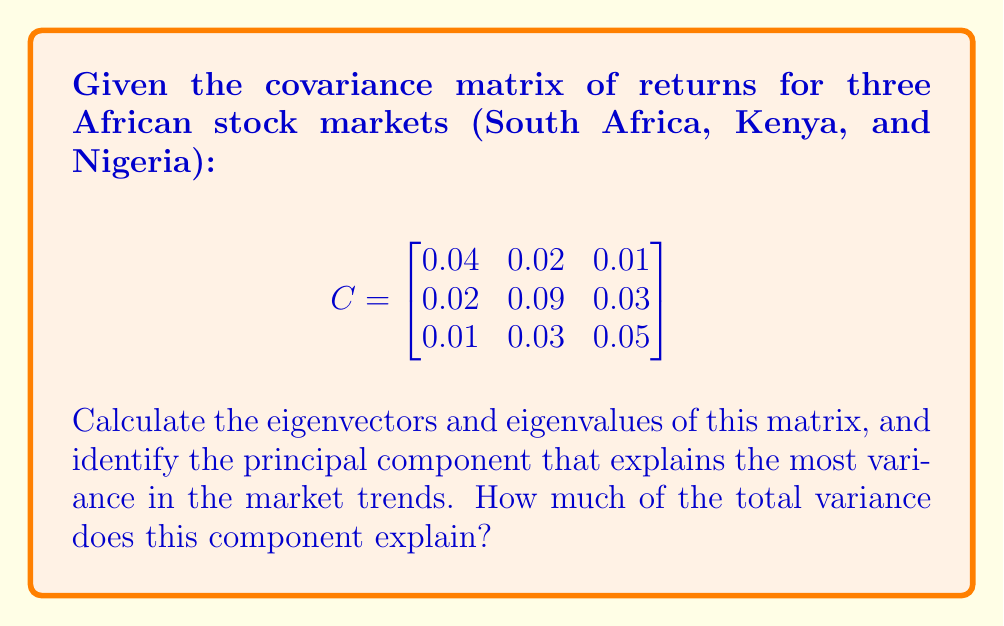Can you answer this question? 1) To find eigenvectors and eigenvalues, we solve the characteristic equation:
   $\det(C - \lambda I) = 0$

2) Expanding the determinant:
   $$(0.04-\lambda)(0.09-\lambda)(0.05-\lambda) - 0.02^2(0.05-\lambda) - 0.01^2(0.09-\lambda) - 0.03^2(0.04-\lambda) + 2(0.02)(0.01)(0.03) = 0$$

3) Solving this equation (using a computer algebra system due to complexity):
   $\lambda_1 \approx 0.1046$
   $\lambda_2 \approx 0.0608$
   $\lambda_3 \approx 0.0246$

4) The corresponding normalized eigenvectors are:
   $$v_1 \approx \begin{bmatrix} 0.2673 \\ 0.9308 \\ 0.2491 \end{bmatrix}$$
   $$v_2 \approx \begin{bmatrix} -0.2785 \\ 0.1776 \\ 0.9437 \end{bmatrix}$$
   $$v_3 \approx \begin{bmatrix} 0.9226 \\ -0.3199 \\ 0.2183 \end{bmatrix}$$

5) The principal component that explains the most variance is the eigenvector corresponding to the largest eigenvalue, which is $v_1$.

6) To calculate the proportion of variance explained by this component:
   Total variance = sum of eigenvalues = 0.1046 + 0.0608 + 0.0246 = 0.19

   Proportion = $\frac{0.1046}{0.19} \approx 0.5505$ or about 55.05%
Answer: The principal component is $\begin{bmatrix} 0.2673 \\ 0.9308 \\ 0.2491 \end{bmatrix}$, explaining 55.05% of total variance. 